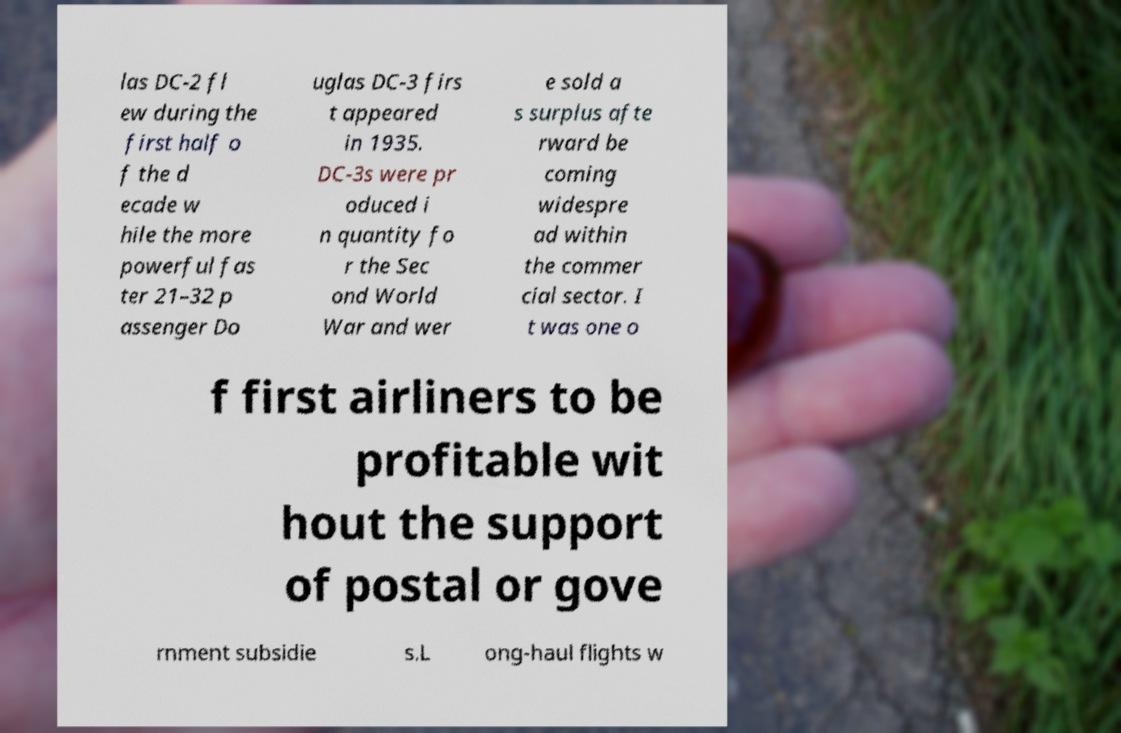Could you assist in decoding the text presented in this image and type it out clearly? las DC-2 fl ew during the first half o f the d ecade w hile the more powerful fas ter 21–32 p assenger Do uglas DC-3 firs t appeared in 1935. DC-3s were pr oduced i n quantity fo r the Sec ond World War and wer e sold a s surplus afte rward be coming widespre ad within the commer cial sector. I t was one o f first airliners to be profitable wit hout the support of postal or gove rnment subsidie s.L ong-haul flights w 